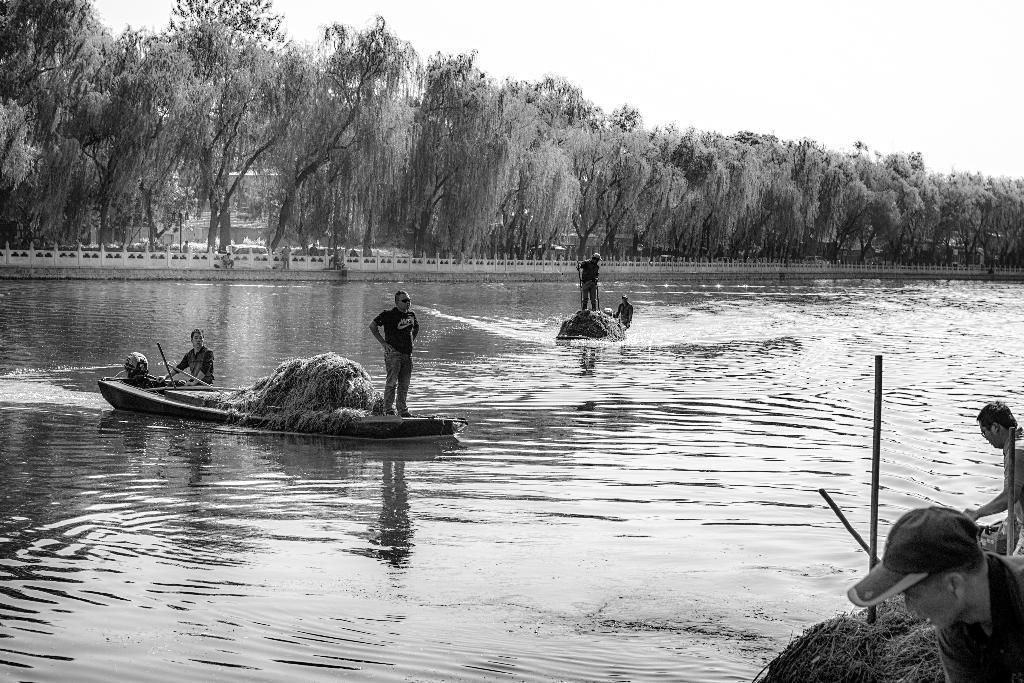In one or two sentences, can you explain what this image depicts? In the left side a man is standing on a boat, this is water. These are the trees in the long back side of an image. 